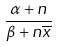<formula> <loc_0><loc_0><loc_500><loc_500>\frac { \alpha + n } { \beta + n \overline { x } }</formula> 